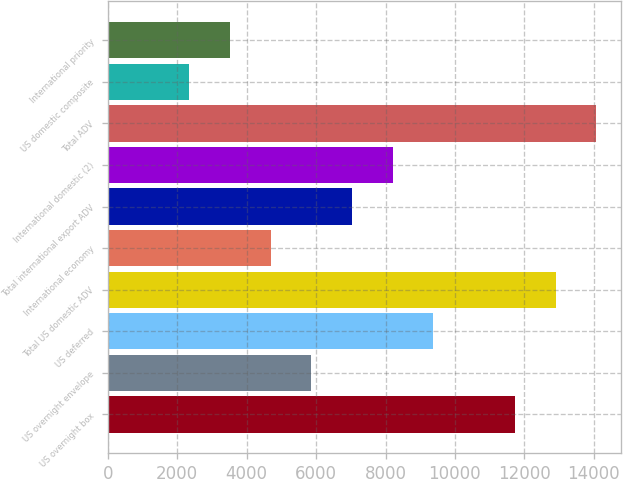Convert chart to OTSL. <chart><loc_0><loc_0><loc_500><loc_500><bar_chart><fcel>US overnight box<fcel>US overnight envelope<fcel>US deferred<fcel>Total US domestic ADV<fcel>International economy<fcel>Total international export ADV<fcel>International domestic (2)<fcel>Total ADV<fcel>US domestic composite<fcel>International priority<nl><fcel>11726<fcel>5863.67<fcel>9381.08<fcel>12898.5<fcel>4691.2<fcel>7036.14<fcel>8208.61<fcel>14071<fcel>2346.26<fcel>3518.73<nl></chart> 